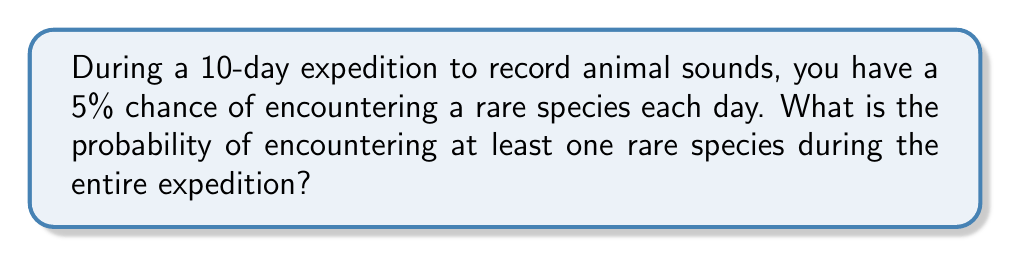Can you answer this question? Let's approach this step-by-step:

1) First, we need to calculate the probability of not encountering a rare species on a single day. This is the complement of encountering a rare species:

   $P(\text{no rare species on one day}) = 1 - 0.05 = 0.95$

2) For the entire 10-day expedition, we need to calculate the probability of not encountering any rare species on all 10 days. Since the events are independent, we multiply the probabilities:

   $P(\text{no rare species for 10 days}) = 0.95^{10}$

3) Now, we can calculate this:

   $0.95^{10} \approx 0.5987$

4) This gives us the probability of not encountering any rare species during the expedition. However, we want the probability of encountering at least one rare species, which is the complement of this probability:

   $P(\text{at least one rare species}) = 1 - P(\text{no rare species for 10 days})$

5) Therefore, our final calculation is:

   $P(\text{at least one rare species}) = 1 - 0.5987 \approx 0.4013$

6) Converting to a percentage:

   $0.4013 \times 100\% \approx 40.13\%$
Answer: 40.13% 